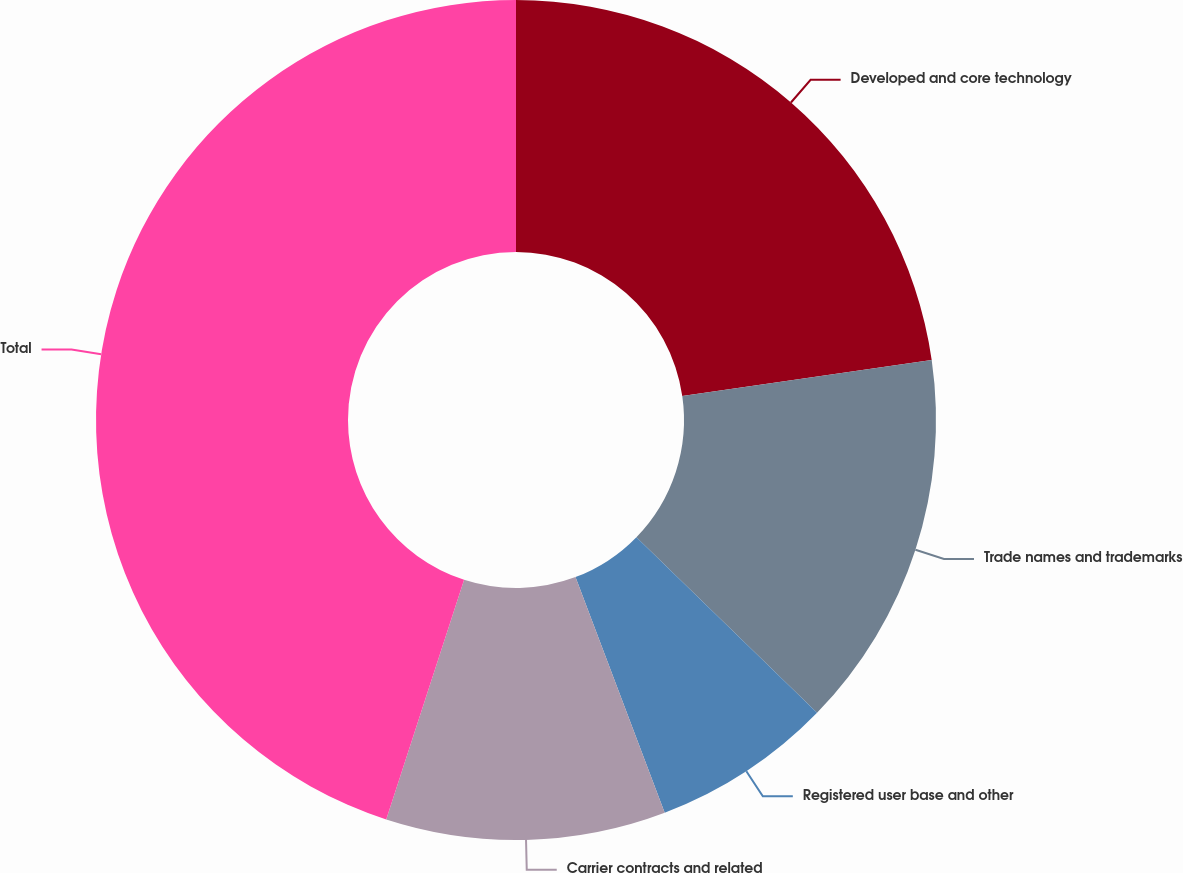Convert chart to OTSL. <chart><loc_0><loc_0><loc_500><loc_500><pie_chart><fcel>Developed and core technology<fcel>Trade names and trademarks<fcel>Registered user base and other<fcel>Carrier contracts and related<fcel>Total<nl><fcel>22.72%<fcel>14.56%<fcel>6.96%<fcel>10.76%<fcel>45.0%<nl></chart> 